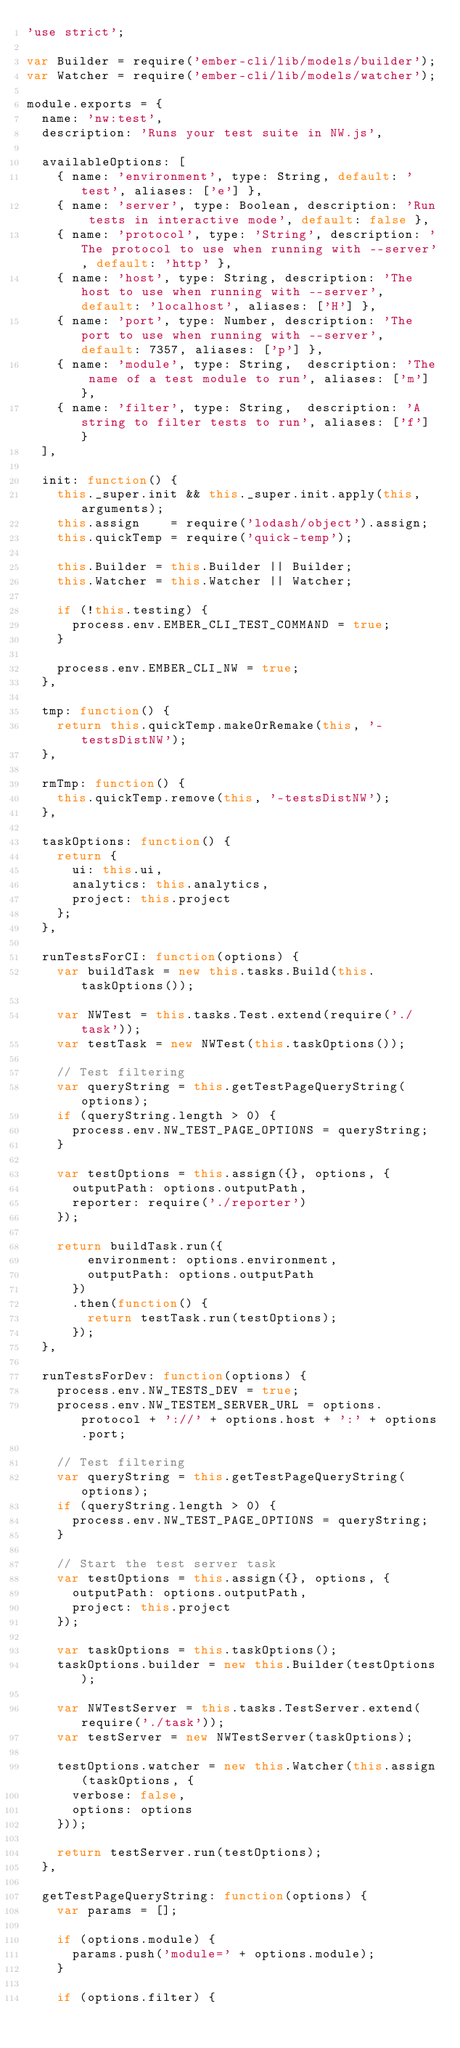<code> <loc_0><loc_0><loc_500><loc_500><_JavaScript_>'use strict';

var Builder = require('ember-cli/lib/models/builder');
var Watcher = require('ember-cli/lib/models/watcher');

module.exports = {
  name: 'nw:test',
  description: 'Runs your test suite in NW.js',

  availableOptions: [
    { name: 'environment', type: String, default: 'test', aliases: ['e'] },
    { name: 'server', type: Boolean, description: 'Run tests in interactive mode', default: false },
    { name: 'protocol', type: 'String', description: 'The protocol to use when running with --server', default: 'http' },
    { name: 'host', type: String, description: 'The host to use when running with --server', default: 'localhost', aliases: ['H'] },
    { name: 'port', type: Number, description: 'The port to use when running with --server', default: 7357, aliases: ['p'] },
    { name: 'module', type: String,  description: 'The name of a test module to run', aliases: ['m'] },
    { name: 'filter', type: String,  description: 'A string to filter tests to run', aliases: ['f'] }
  ],

  init: function() {
    this._super.init && this._super.init.apply(this, arguments);
    this.assign    = require('lodash/object').assign;
    this.quickTemp = require('quick-temp');

    this.Builder = this.Builder || Builder;
    this.Watcher = this.Watcher || Watcher;

    if (!this.testing) {
      process.env.EMBER_CLI_TEST_COMMAND = true;
    }

    process.env.EMBER_CLI_NW = true;
  },

  tmp: function() {
    return this.quickTemp.makeOrRemake(this, '-testsDistNW');
  },

  rmTmp: function() {
    this.quickTemp.remove(this, '-testsDistNW');
  },

  taskOptions: function() {
    return {
      ui: this.ui,
      analytics: this.analytics,
      project: this.project
    };
  },

  runTestsForCI: function(options) {
    var buildTask = new this.tasks.Build(this.taskOptions());

    var NWTest = this.tasks.Test.extend(require('./task'));
    var testTask = new NWTest(this.taskOptions());

    // Test filtering
    var queryString = this.getTestPageQueryString(options);
    if (queryString.length > 0) {
      process.env.NW_TEST_PAGE_OPTIONS = queryString;
    }

    var testOptions = this.assign({}, options, {
      outputPath: options.outputPath,
      reporter: require('./reporter')
    });

    return buildTask.run({
        environment: options.environment,
        outputPath: options.outputPath
      })
      .then(function() {
        return testTask.run(testOptions);
      });
  },

  runTestsForDev: function(options) {
    process.env.NW_TESTS_DEV = true;
    process.env.NW_TESTEM_SERVER_URL = options.protocol + '://' + options.host + ':' + options.port;

    // Test filtering
    var queryString = this.getTestPageQueryString(options);
    if (queryString.length > 0) {
      process.env.NW_TEST_PAGE_OPTIONS = queryString;
    }

    // Start the test server task
    var testOptions = this.assign({}, options, {
      outputPath: options.outputPath,
      project: this.project
    });

    var taskOptions = this.taskOptions();
    taskOptions.builder = new this.Builder(testOptions);

    var NWTestServer = this.tasks.TestServer.extend(require('./task'));
    var testServer = new NWTestServer(taskOptions);

    testOptions.watcher = new this.Watcher(this.assign(taskOptions, {
      verbose: false,
      options: options
    }));

    return testServer.run(testOptions);
  },

  getTestPageQueryString: function(options) {
    var params = [];

    if (options.module) {
      params.push('module=' + options.module);
    }

    if (options.filter) {</code> 